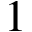Convert formula to latex. <formula><loc_0><loc_0><loc_500><loc_500>1</formula> 